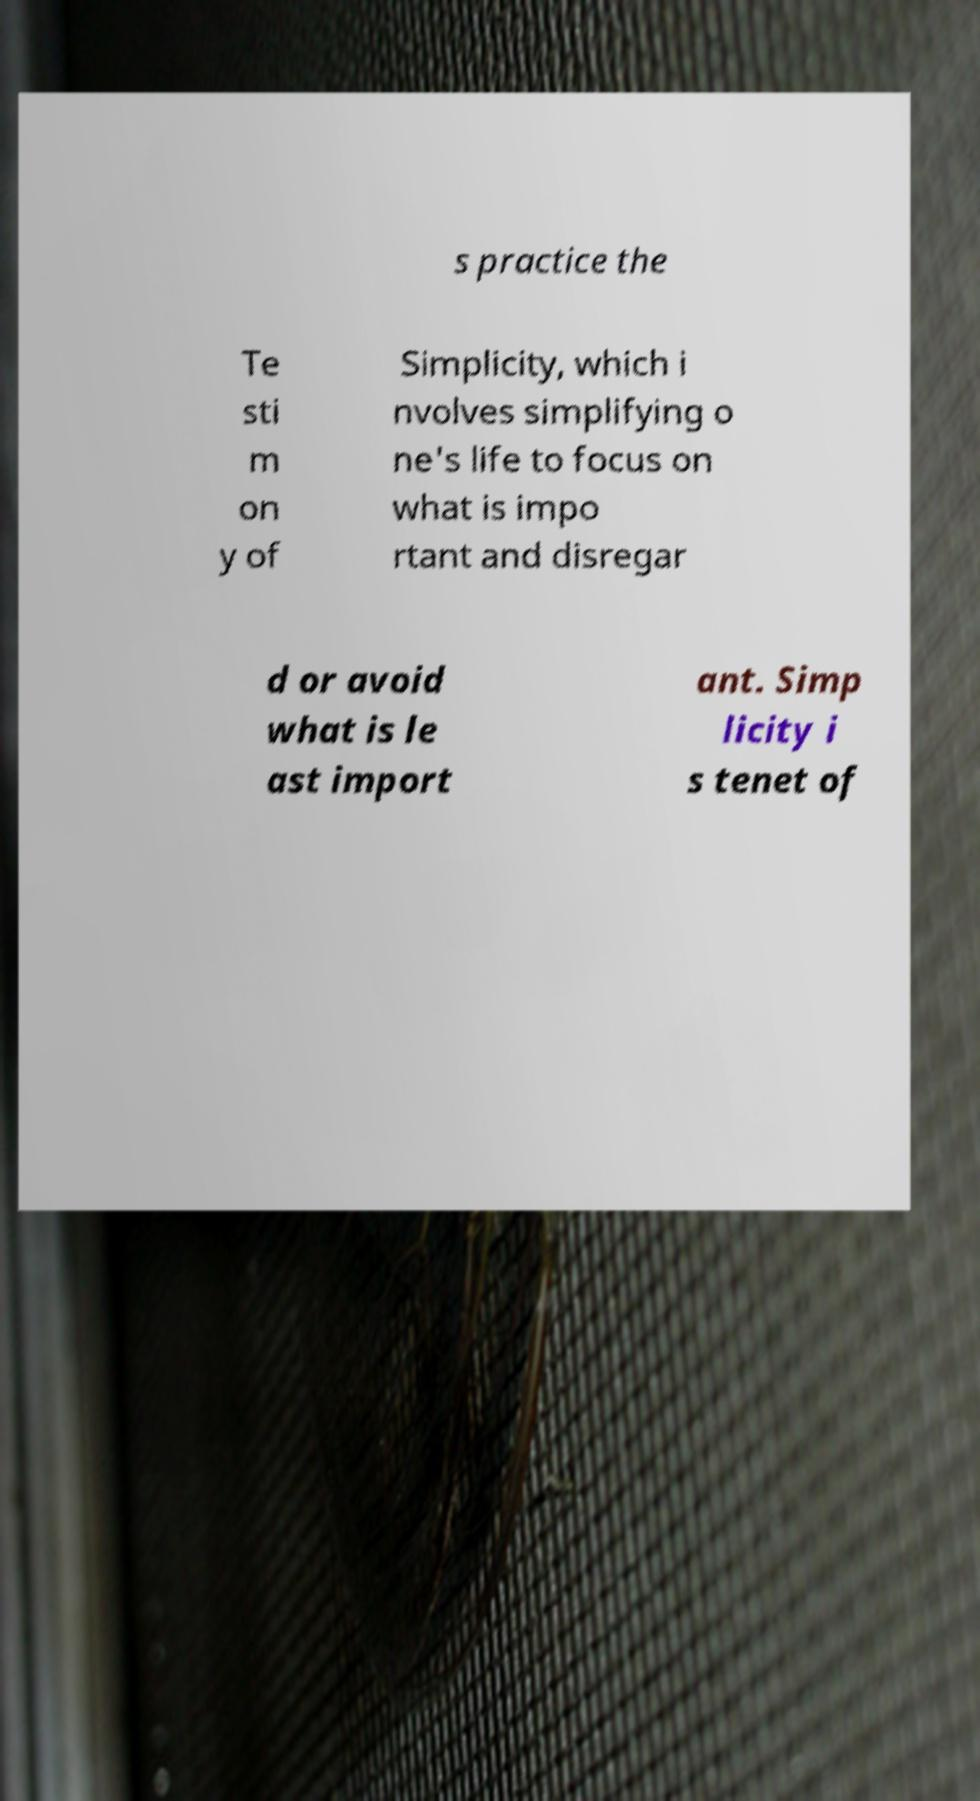What messages or text are displayed in this image? I need them in a readable, typed format. s practice the Te sti m on y of Simplicity, which i nvolves simplifying o ne's life to focus on what is impo rtant and disregar d or avoid what is le ast import ant. Simp licity i s tenet of 